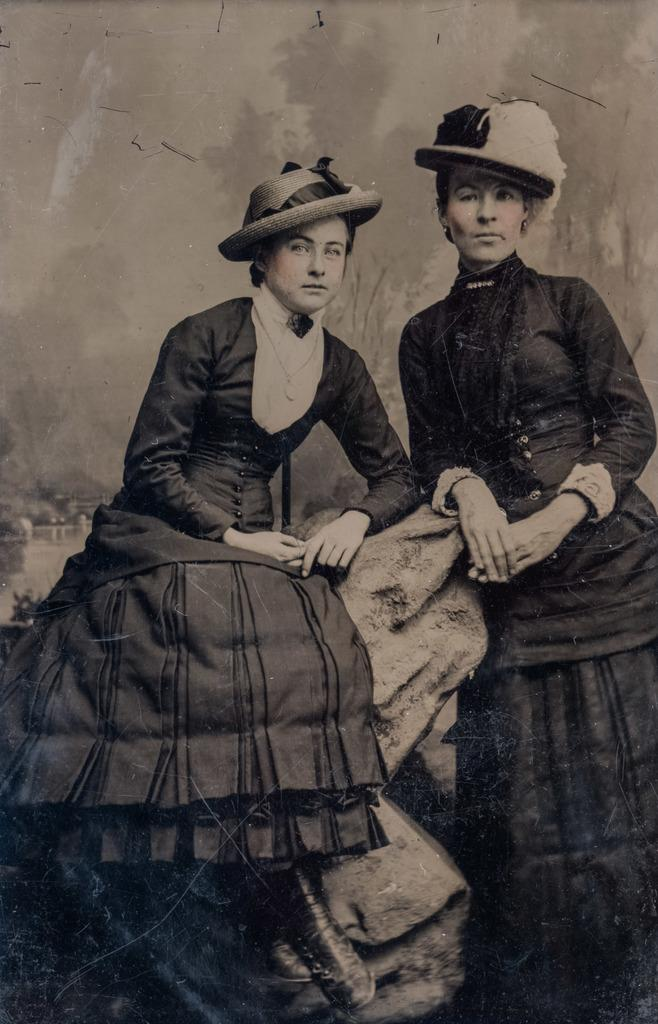How many people are in the image? There are two people in the image. What are the people wearing? Both people are wearing clothes and hats. What are the positions of the two people in the image? One person is sitting, and the other is standing. Can you describe any accessories worn by the people? One person is wearing a neck chain. What type of tiger can be seen walking on the sidewalk in the image? There is no tiger or sidewalk present in the image. Can you tell me what type of badge the person is wearing in the image? There is no badge mentioned or visible in the image. 